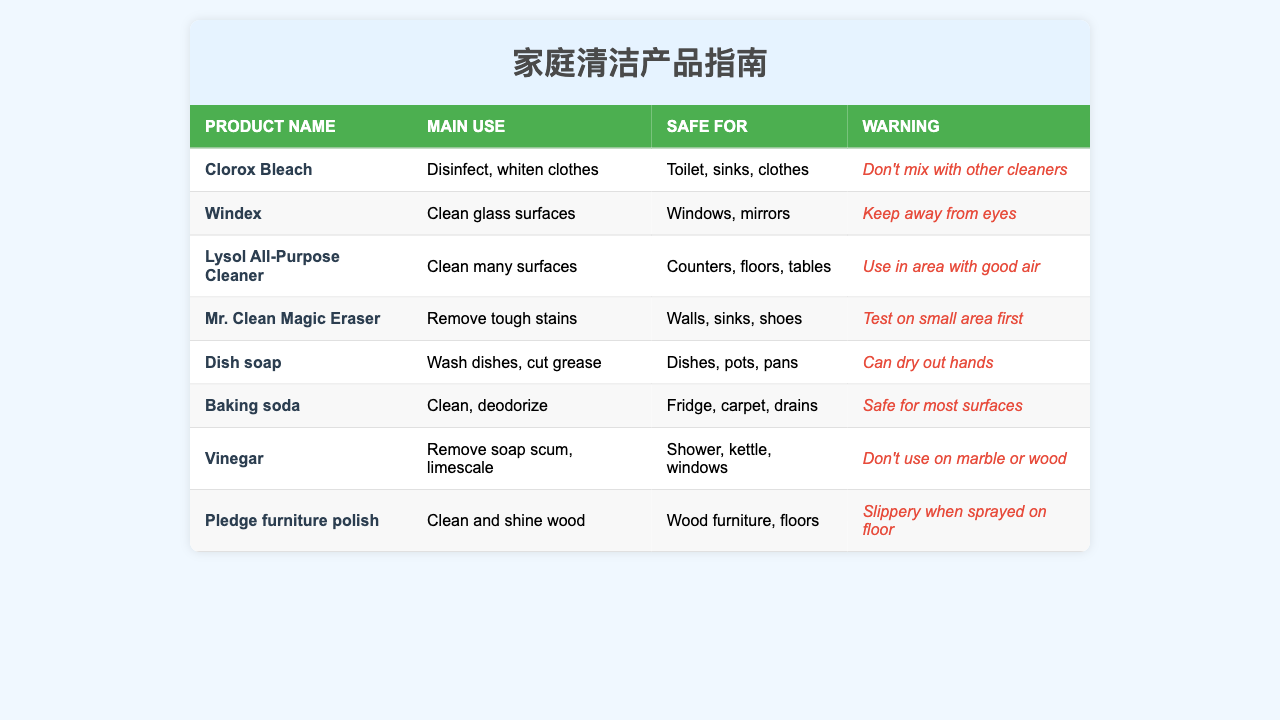What is the main use of Clorox Bleach? In the table, the main use of Clorox Bleach is listed as "Disinfect, whiten clothes."
Answer: Disinfect, whiten clothes Is Windex safe for use on mirrors? Looking at the table, Windex is mentioned as "Safe for" windows and mirrors.
Answer: Yes What does Lysol All-Purpose Cleaner clean? The table states that Lysol All-Purpose Cleaner is used to "Clean many surfaces," specifically counters, floors, and tables.
Answer: Clean many surfaces Which product can dry out hands? The table specifies that Dish soap "Can dry out hands," providing the information needed to answer this.
Answer: Dish soap What is the warning for using Mr. Clean Magic Eraser? The table indicates that the warning for Mr. Clean Magic Eraser is to "Test on small area first."
Answer: Test on small area first Is vinegar safe for marble surfaces? According to the table, the warning for vinegar states "Don't use on marble or wood," indicating it is not safe for marble.
Answer: No Which product is used to remove soap scum? The table indicates that vinegar is used to "Remove soap scum, limescale," which answers the question directly.
Answer: Vinegar How many products are safe for toilet use? In the table, Clorox Bleach is shown as "Safe for" the toilet, and it's the only product mentioned, resulting in a total of one product.
Answer: 1 What are the safe surfaces for baking soda? The table lists that baking soda is "Safe for" fridge, carpet, and drains. This provides the answer needed for the question.
Answer: Fridge, carpet, drains Which cleaning product requires good air while being used? The table states that Lysol All-Purpose Cleaner should be used in an area with good air, directly answering the question.
Answer: Lysol All-Purpose Cleaner 